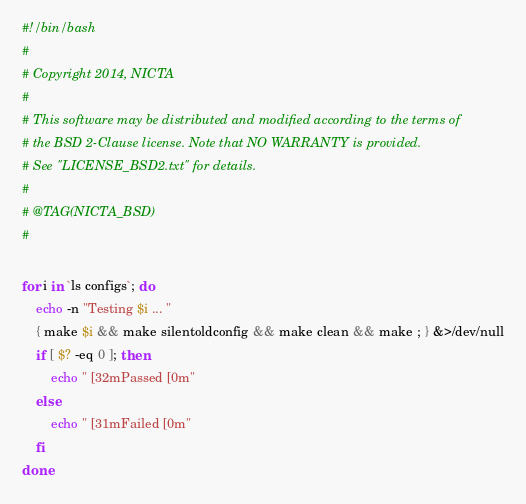Convert code to text. <code><loc_0><loc_0><loc_500><loc_500><_Bash_>#!/bin/bash
#
# Copyright 2014, NICTA
#
# This software may be distributed and modified according to the terms of
# the BSD 2-Clause license. Note that NO WARRANTY is provided.
# See "LICENSE_BSD2.txt" for details.
#
# @TAG(NICTA_BSD)
#

for i in `ls configs`; do
    echo -n "Testing $i ... "
    { make $i && make silentoldconfig && make clean && make ; } &>/dev/null
    if [ $? -eq 0 ]; then
        echo "[32mPassed[0m"
    else
        echo "[31mFailed[0m"
    fi
done
</code> 